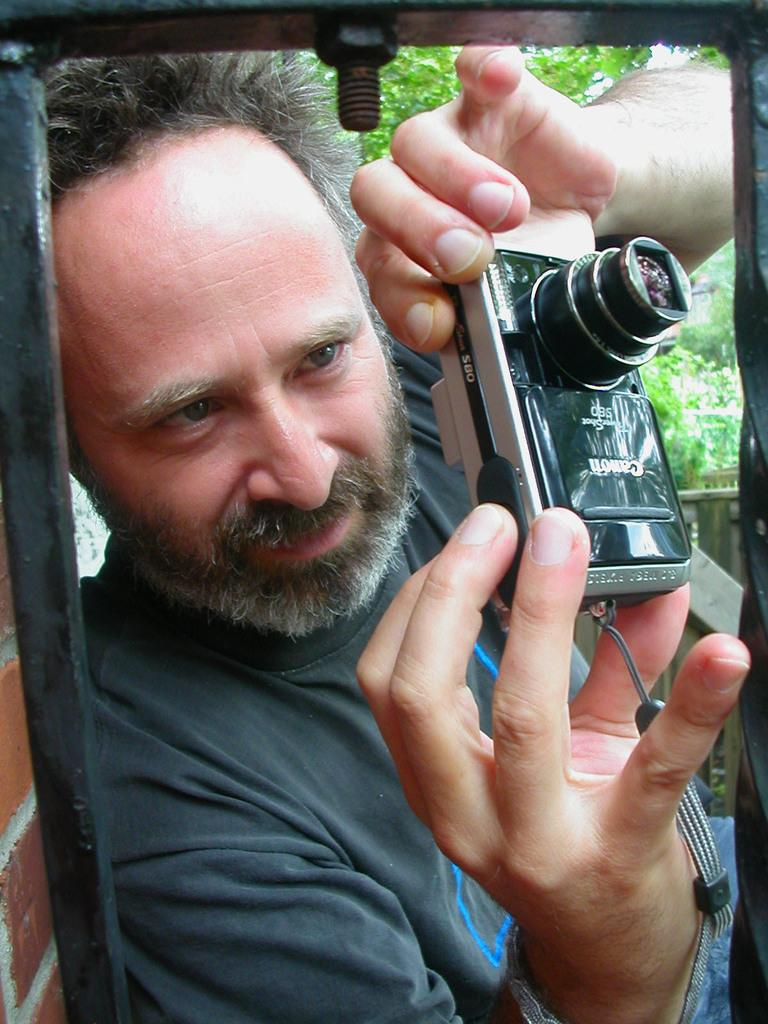Who is present in the image? There is a man in the image. What is the man doing in the image? The man is capturing a photo. What can be seen in the background of the image? There are trees visible in the image. What type of protest is happening in the image? There is no protest present in the image; it features a man capturing a photo with trees in the background. 